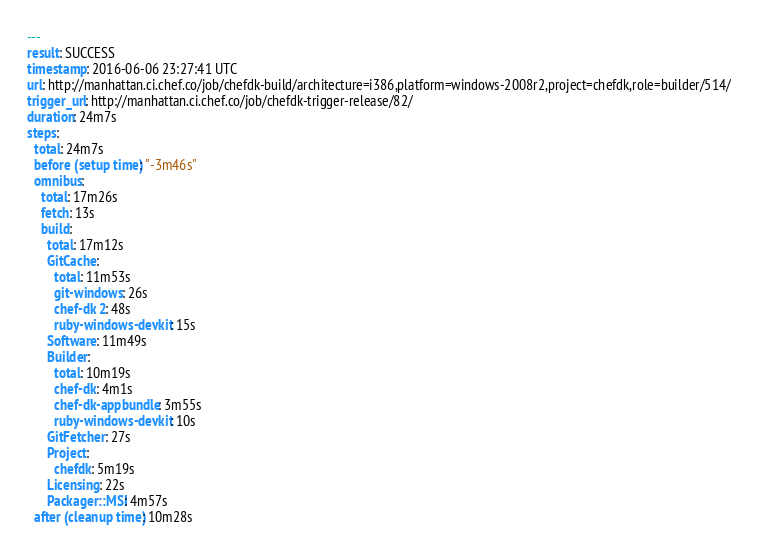<code> <loc_0><loc_0><loc_500><loc_500><_YAML_>---
result: SUCCESS
timestamp: 2016-06-06 23:27:41 UTC
url: http://manhattan.ci.chef.co/job/chefdk-build/architecture=i386,platform=windows-2008r2,project=chefdk,role=builder/514/
trigger_url: http://manhattan.ci.chef.co/job/chefdk-trigger-release/82/
duration: 24m7s
steps:
  total: 24m7s
  before (setup time): "-3m46s"
  omnibus:
    total: 17m26s
    fetch: 13s
    build:
      total: 17m12s
      GitCache:
        total: 11m53s
        git-windows: 26s
        chef-dk 2: 48s
        ruby-windows-devkit: 15s
      Software: 11m49s
      Builder:
        total: 10m19s
        chef-dk: 4m1s
        chef-dk-appbundle: 3m55s
        ruby-windows-devkit: 10s
      GitFetcher: 27s
      Project:
        chefdk: 5m19s
      Licensing: 22s
      Packager::MSI: 4m57s
  after (cleanup time): 10m28s
</code> 